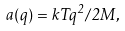<formula> <loc_0><loc_0><loc_500><loc_500>a ( q ) = k T q ^ { 2 } / 2 M ,</formula> 